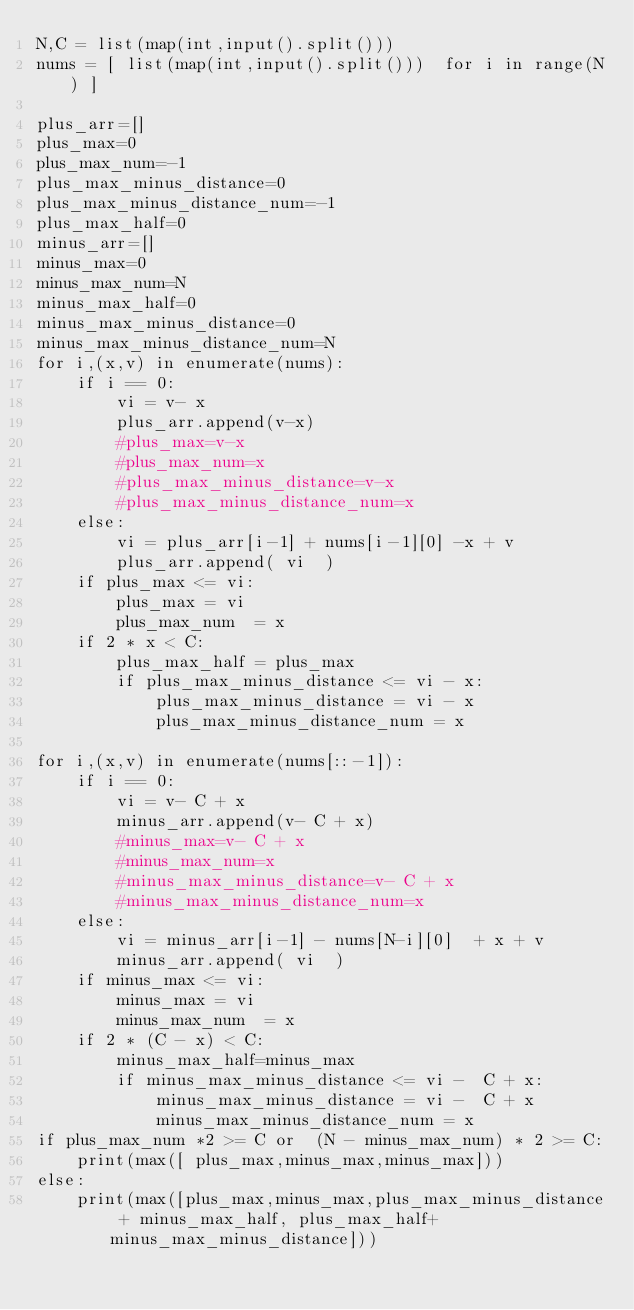<code> <loc_0><loc_0><loc_500><loc_500><_Python_>N,C = list(map(int,input().split()))
nums = [ list(map(int,input().split()))  for i in range(N) ]

plus_arr=[]
plus_max=0
plus_max_num=-1
plus_max_minus_distance=0
plus_max_minus_distance_num=-1
plus_max_half=0
minus_arr=[]
minus_max=0
minus_max_num=N
minus_max_half=0
minus_max_minus_distance=0
minus_max_minus_distance_num=N
for i,(x,v) in enumerate(nums):
    if i == 0:
        vi = v- x
        plus_arr.append(v-x)
        #plus_max=v-x
        #plus_max_num=x
        #plus_max_minus_distance=v-x
        #plus_max_minus_distance_num=x
    else:
        vi = plus_arr[i-1] + nums[i-1][0] -x + v
        plus_arr.append( vi  )
    if plus_max <= vi:
        plus_max = vi
        plus_max_num  = x
    if 2 * x < C:
        plus_max_half = plus_max
        if plus_max_minus_distance <= vi - x:
            plus_max_minus_distance = vi - x
            plus_max_minus_distance_num = x

for i,(x,v) in enumerate(nums[::-1]):
    if i == 0:
        vi = v- C + x
        minus_arr.append(v- C + x)
        #minus_max=v- C + x
        #minus_max_num=x
        #minus_max_minus_distance=v- C + x
        #minus_max_minus_distance_num=x
    else:
        vi = minus_arr[i-1] - nums[N-i][0]  + x + v
        minus_arr.append( vi  )
    if minus_max <= vi:
        minus_max = vi
        minus_max_num  = x
    if 2 * (C - x) < C:
        minus_max_half=minus_max
        if minus_max_minus_distance <= vi -  C + x:
            minus_max_minus_distance = vi -  C + x
            minus_max_minus_distance_num = x
if plus_max_num *2 >= C or  (N - minus_max_num) * 2 >= C:
    print(max([ plus_max,minus_max,minus_max]))
else:
    print(max([plus_max,minus_max,plus_max_minus_distance + minus_max_half, plus_max_half+ minus_max_minus_distance]))
</code> 